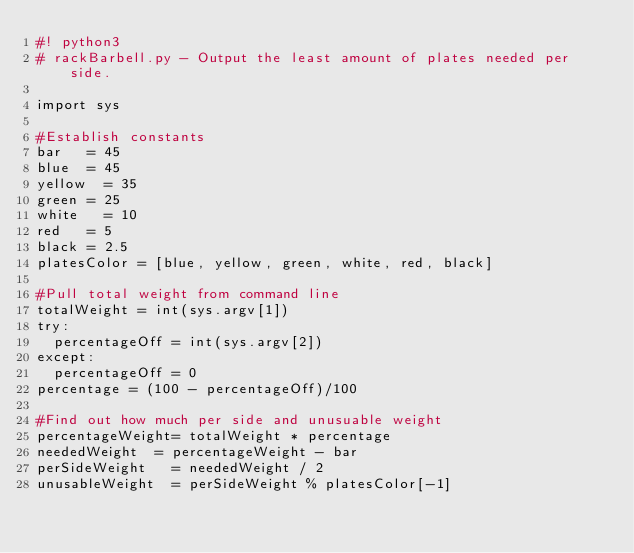<code> <loc_0><loc_0><loc_500><loc_500><_Python_>#! python3
# rackBarbell.py - Output the least amount of plates needed per side. 

import sys

#Establish constants
bar 	= 45
blue 	= 45
yellow	= 35
green	= 25
white 	= 10
red 	= 5
black	= 2.5
platesColor = [blue, yellow, green, white, red, black]
	
#Pull total weight from command line
totalWeight = int(sys.argv[1])
try:
	percentageOff = int(sys.argv[2])
except:
	percentageOff = 0
percentage = (100 - percentageOff)/100

#Find out how much per side and unusuable weight
percentageWeight= totalWeight * percentage
neededWeight 	= percentageWeight - bar
perSideWeight 	= neededWeight / 2
unusableWeight	= perSideWeight % platesColor[-1]</code> 